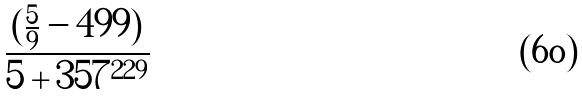Convert formula to latex. <formula><loc_0><loc_0><loc_500><loc_500>\frac { ( \frac { 5 } { 9 } - 4 9 9 ) } { 5 + 3 5 7 ^ { 2 2 9 } }</formula> 